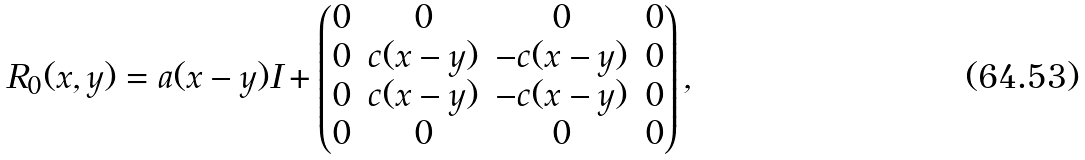<formula> <loc_0><loc_0><loc_500><loc_500>R _ { 0 } ( x , y ) = a ( x - y ) I + \begin{pmatrix} 0 & 0 & 0 & 0 \\ 0 & c ( x - y ) & - c ( x - y ) & 0 \\ 0 & c ( x - y ) & - c ( x - y ) & 0 \\ 0 & 0 & 0 & 0 \end{pmatrix} ,</formula> 